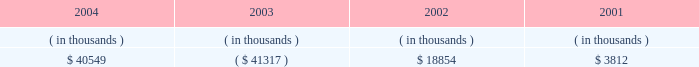Entergy louisiana , inc .
Management's financial discussion and analysis setting any of entergy louisiana's rates .
Therefore , to the extent entergy louisiana's use of the proceeds would ordinarily have reduced its rate base , no change in rate base shall be reflected for ratemaking purposes .
The sec approval for additional return of equity capital is now expired .
Entergy louisiana's receivables from or ( payables to ) the money pool were as follows as of december 31 for each of the following years: .
Money pool activity used $ 81.9 million of entergy louisiana's operating cash flow in 2004 , provided $ 60.2 million in 2003 , and used $ 15.0 million in 2002 .
See note 4 to the domestic utility companies and system energy financial statements for a description of the money pool .
Investing activities the decrease of $ 25.1 million in net cash used by investing activities in 2004 was primarily due to decreased spending on customer service projects , partially offset by increases in spending on transmission projects and fossil plant projects .
The increase of $ 56.0 million in net cash used by investing activities in 2003 was primarily due to increased spending on customer service , transmission , and nuclear projects .
Financing activities the decrease of $ 404.4 million in net cash used by financing activities in 2004 was primarily due to : 2022 the net issuance of $ 98.0 million of long-term debt in 2004 compared to the retirement of $ 261.0 million in 2022 a principal payment of $ 14.8 million in 2004 for the waterford lease obligation compared to a principal payment of $ 35.4 million in 2003 ; and 2022 a decrease of $ 29.0 million in common stock dividends paid .
The decrease of $ 105.5 million in net cash used by financing activities in 2003 was primarily due to : 2022 a decrease of $ 125.9 million in common stock dividends paid ; and 2022 the repurchase of $ 120 million of common stock from entergy corporation in 2002 .
The decrease in net cash used in 2003 was partially offset by the following : 2022 the retirement in 2003 of $ 150 million of 8.5% ( 8.5 % ) series first mortgage bonds compared to the net retirement of $ 134.6 million of first mortgage bonds in 2002 ; and 2022 principal payments of $ 35.4 million in 2003 for the waterford 3 lease obligation compared to principal payments of $ 15.9 million in 2002 .
See note 5 to the domestic utility companies and system energy financial statements for details of long-term debt .
Uses of capital entergy louisiana requires capital resources for : 2022 construction and other capital investments ; 2022 debt and preferred stock maturities ; 2022 working capital purposes , including the financing of fuel and purchased power costs ; and 2022 dividend and interest payments. .
What is the difference of the payment for waterford lease obligation between 2003 and 2004? 
Computations: (35.4 - 14.8)
Answer: 20.6. 